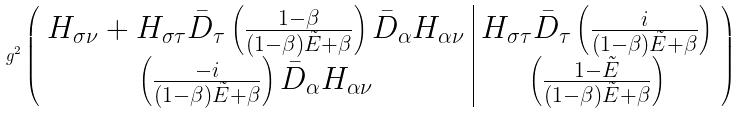Convert formula to latex. <formula><loc_0><loc_0><loc_500><loc_500>g ^ { 2 } \left ( \begin{array} { c | c } H _ { \sigma \nu } + H _ { \sigma \tau } \bar { D } _ { \tau } \left ( \frac { 1 - \beta } { ( 1 - \beta ) \tilde { E } + \beta } \right ) \bar { D } _ { \alpha } H _ { \alpha \nu } & H _ { \sigma \tau } \bar { D } _ { \tau } \left ( \frac { i } { ( 1 - \beta ) \tilde { E } + \beta } \right ) \\ \left ( \frac { - i } { ( 1 - \beta ) \tilde { E } + \beta } \right ) \bar { D } _ { \alpha } H _ { \alpha \nu } & \left ( \frac { 1 - \tilde { E } } { ( 1 - \beta ) \tilde { E } + \beta } \right ) \end{array} \right )</formula> 